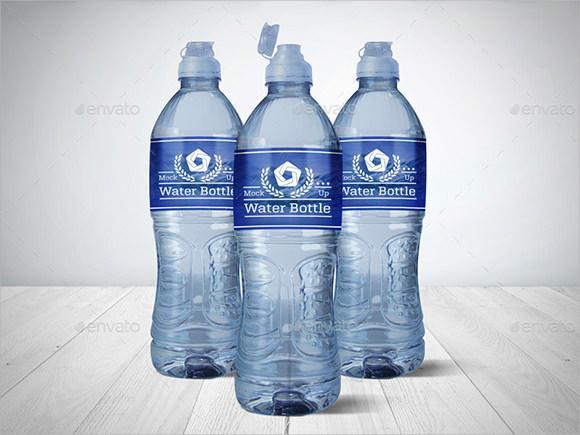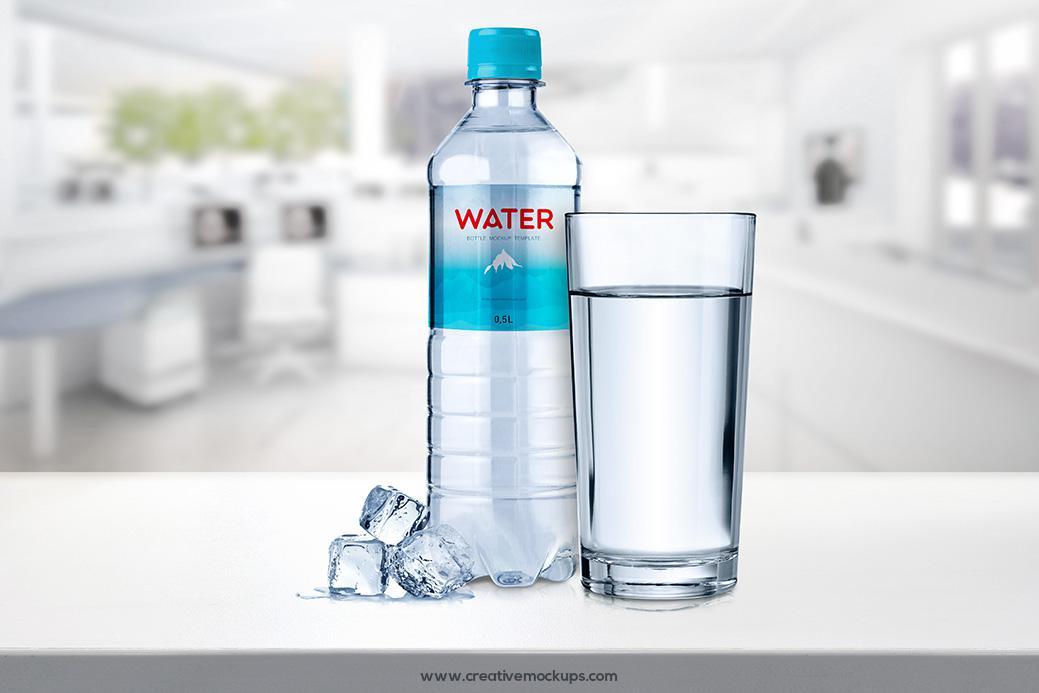The first image is the image on the left, the second image is the image on the right. Examine the images to the left and right. Is the description "The left image contains no more than one bottle." accurate? Answer yes or no. No. The first image is the image on the left, the second image is the image on the right. Examine the images to the left and right. Is the description "Three bottles are grouped together in the image on the left." accurate? Answer yes or no. Yes. 